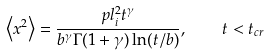Convert formula to latex. <formula><loc_0><loc_0><loc_500><loc_500>\left < x ^ { 2 } \right > = \frac { p l _ { i } ^ { 2 } t ^ { \gamma } } { b ^ { \gamma } \Gamma ( 1 + \gamma ) \ln ( t / b ) } , \quad t < t _ { c r }</formula> 